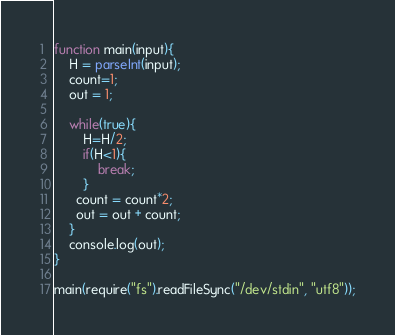<code> <loc_0><loc_0><loc_500><loc_500><_JavaScript_>function main(input){
    H = parseInt(input);
    count=1;
    out = 1;
  
    while(true){
        H=H/2;
        if(H<1){            
            break;
        }
      count = count*2;
      out = out + count;
    }
  	console.log(out);
}

main(require("fs").readFileSync("/dev/stdin", "utf8"));</code> 